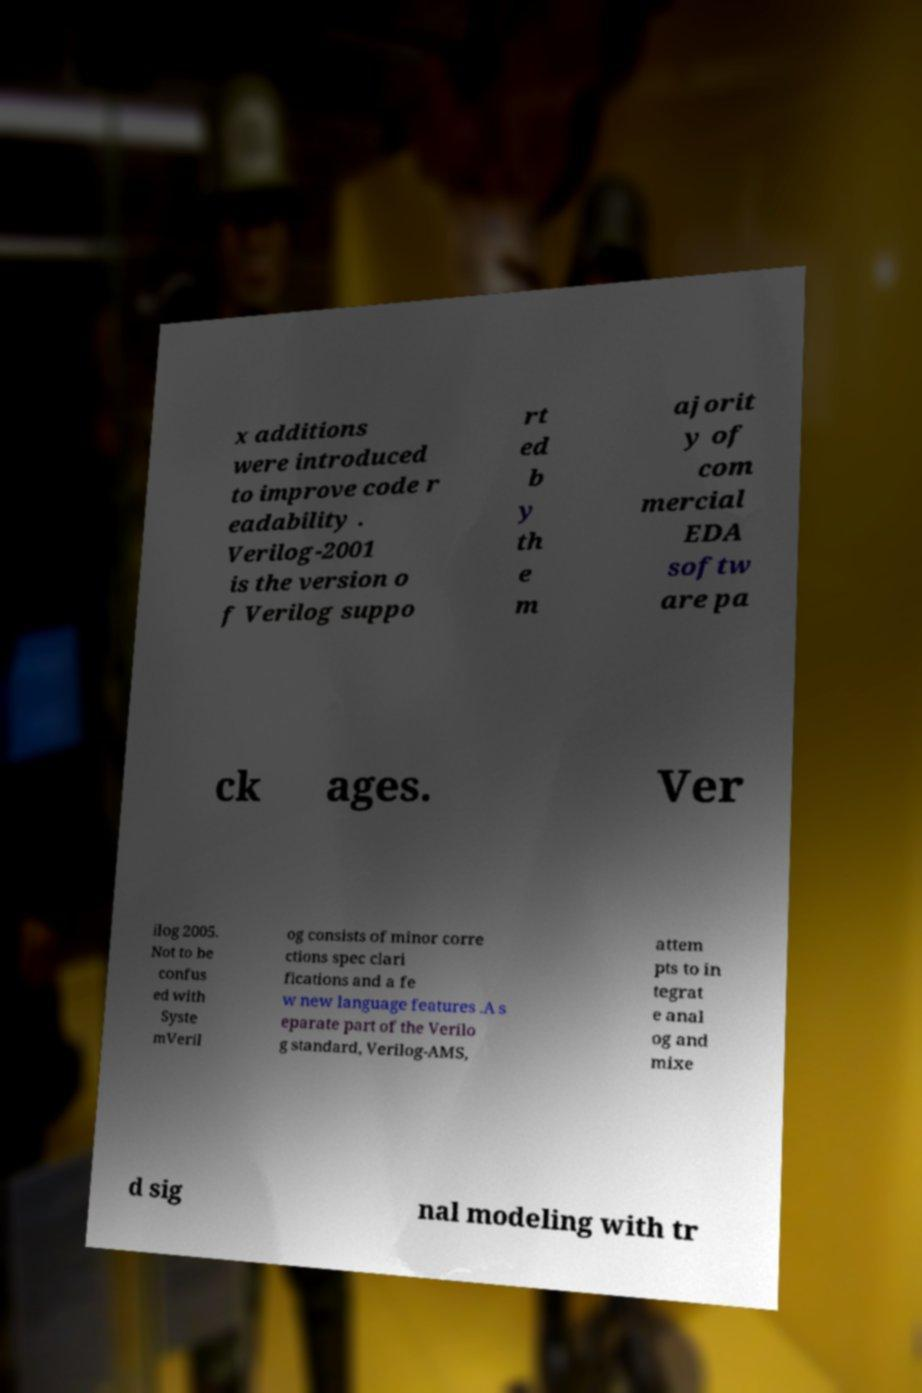I need the written content from this picture converted into text. Can you do that? x additions were introduced to improve code r eadability . Verilog-2001 is the version o f Verilog suppo rt ed b y th e m ajorit y of com mercial EDA softw are pa ck ages. Ver ilog 2005. Not to be confus ed with Syste mVeril og consists of minor corre ctions spec clari fications and a fe w new language features .A s eparate part of the Verilo g standard, Verilog-AMS, attem pts to in tegrat e anal og and mixe d sig nal modeling with tr 